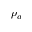Convert formula to latex. <formula><loc_0><loc_0><loc_500><loc_500>\rho _ { a }</formula> 